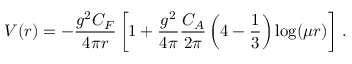Convert formula to latex. <formula><loc_0><loc_0><loc_500><loc_500>V ( r ) = - \frac { g ^ { 2 } C _ { F } } { 4 \pi r } \left [ 1 + \frac { g ^ { 2 } } { 4 \pi } \frac { C _ { A } } { 2 \pi } \left ( 4 - \frac { 1 } { 3 } \right ) \log ( \mu r ) \right ] \, .</formula> 